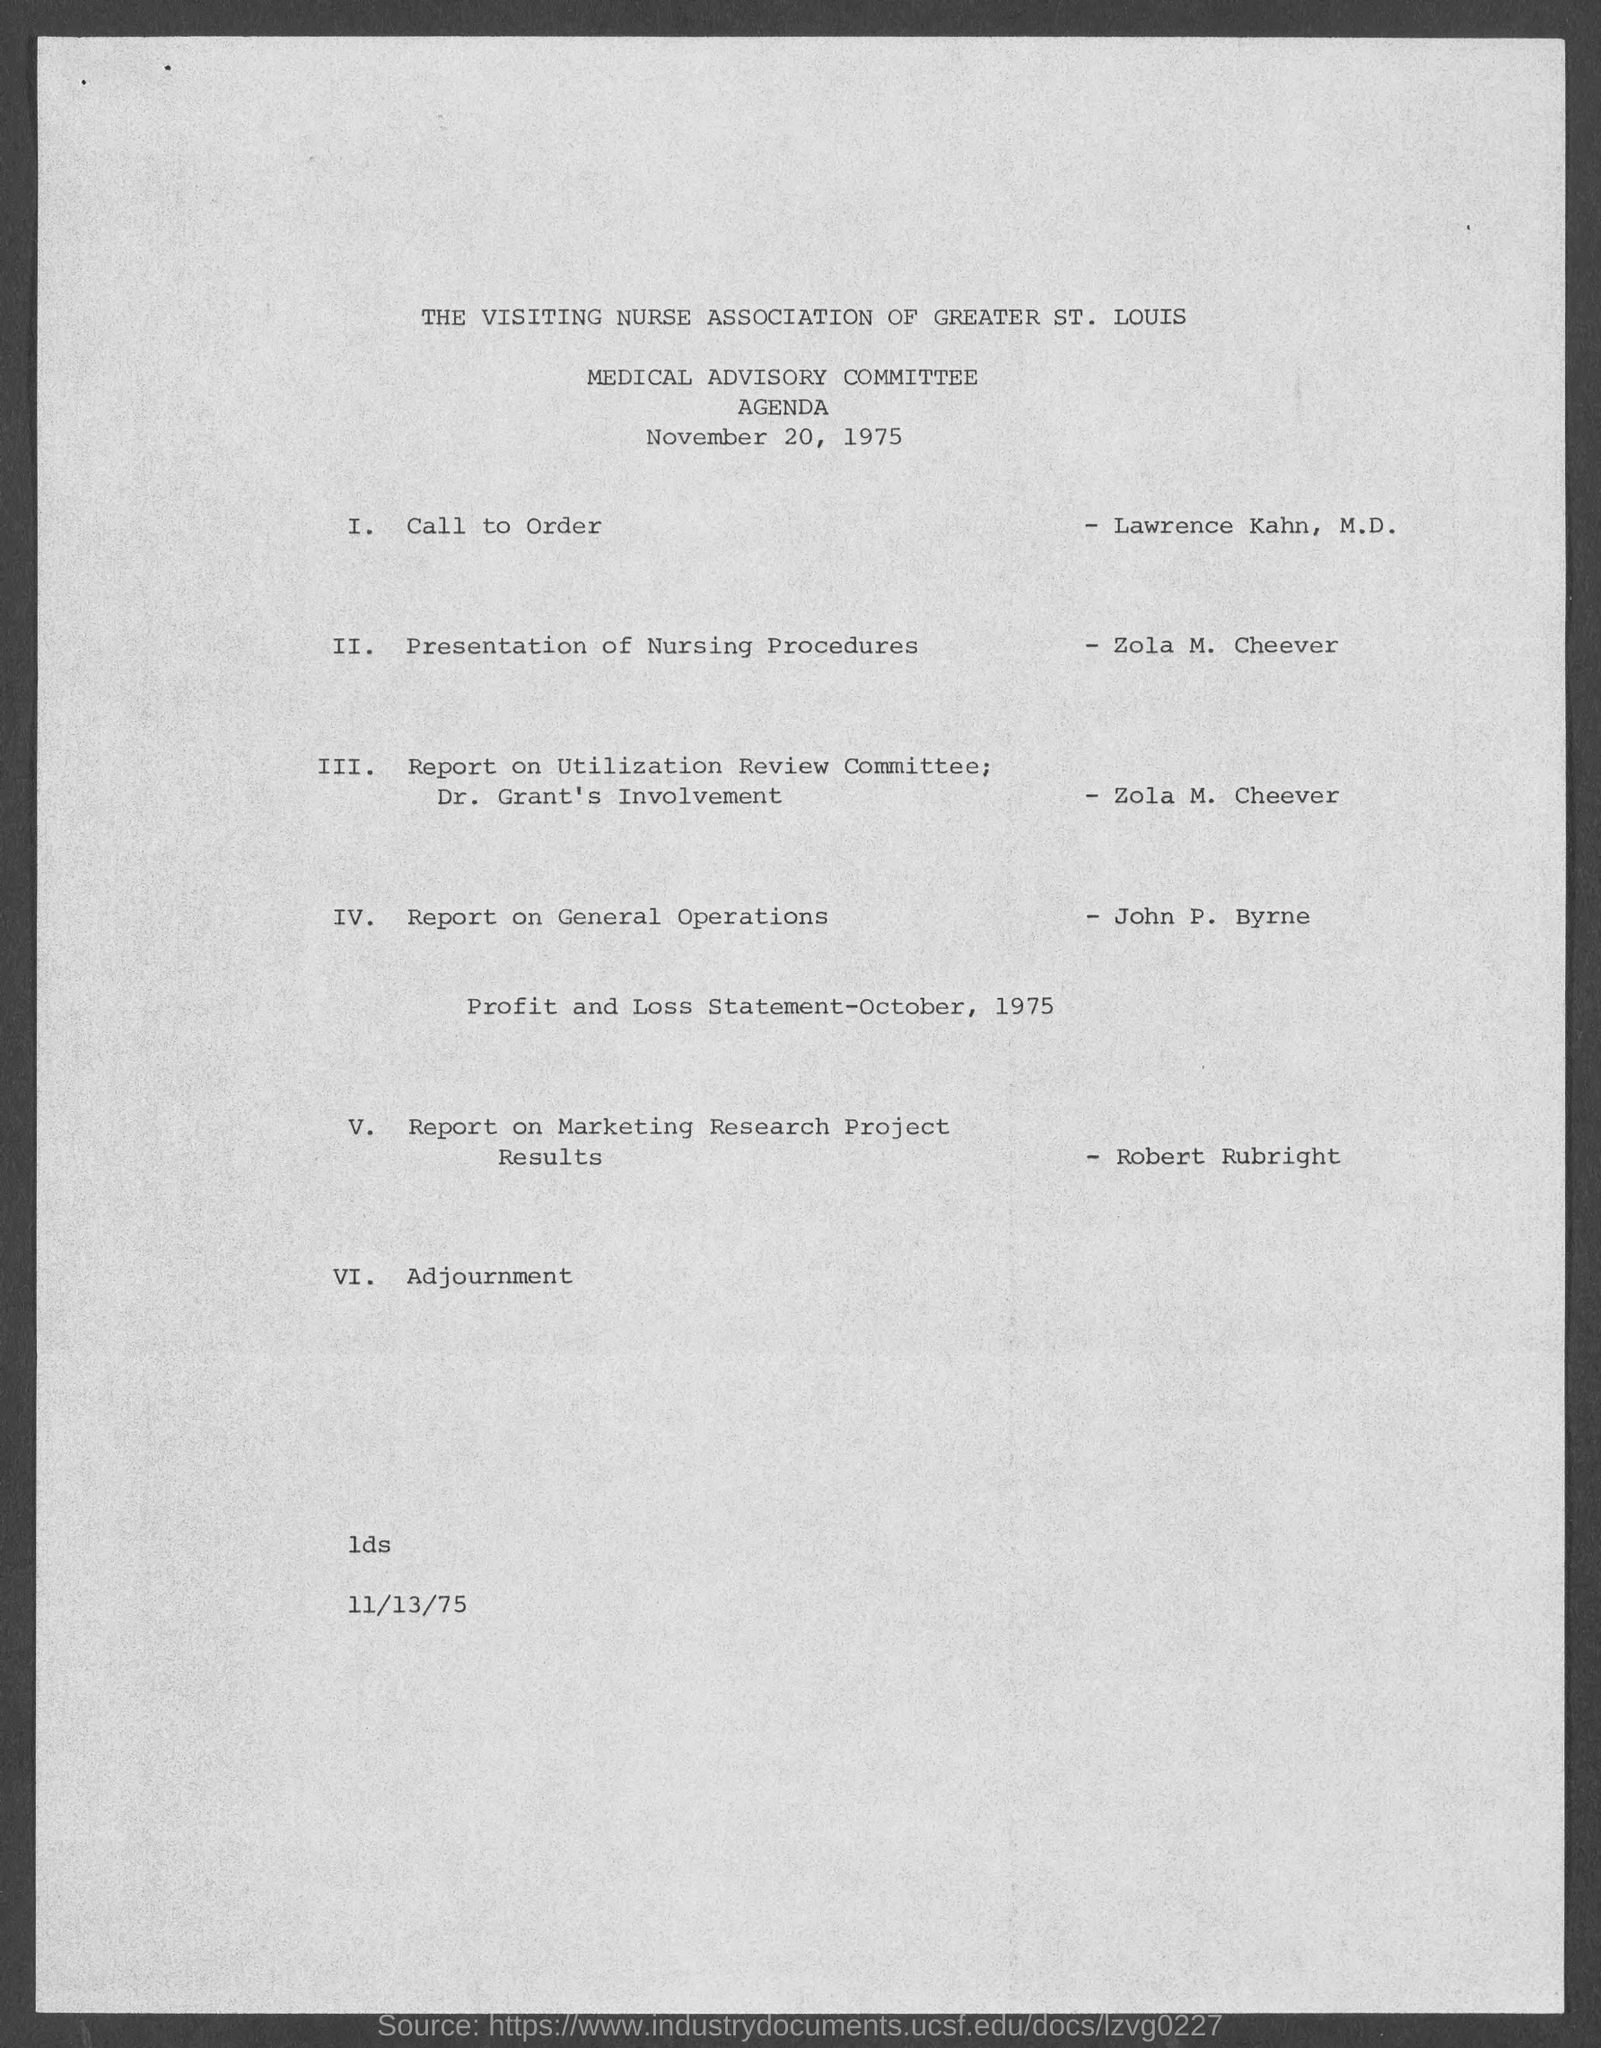Identify some key points in this picture. The date of the Agenda is November 20, 1975. 